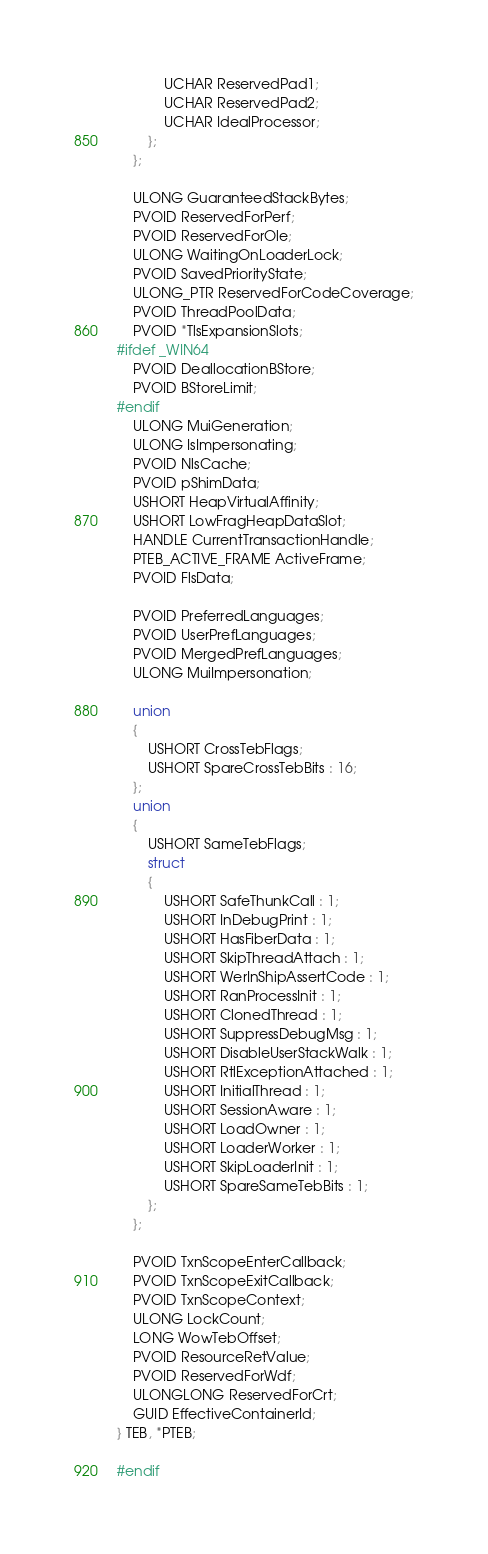Convert code to text. <code><loc_0><loc_0><loc_500><loc_500><_C_>            UCHAR ReservedPad1;
            UCHAR ReservedPad2;
            UCHAR IdealProcessor;
        };
    };

    ULONG GuaranteedStackBytes;
    PVOID ReservedForPerf;
    PVOID ReservedForOle;
    ULONG WaitingOnLoaderLock;
    PVOID SavedPriorityState;
    ULONG_PTR ReservedForCodeCoverage;
    PVOID ThreadPoolData;
    PVOID *TlsExpansionSlots;
#ifdef _WIN64
    PVOID DeallocationBStore;
    PVOID BStoreLimit;
#endif
    ULONG MuiGeneration;
    ULONG IsImpersonating;
    PVOID NlsCache;
    PVOID pShimData;
    USHORT HeapVirtualAffinity;
    USHORT LowFragHeapDataSlot;
    HANDLE CurrentTransactionHandle;
    PTEB_ACTIVE_FRAME ActiveFrame;
    PVOID FlsData;

    PVOID PreferredLanguages;
    PVOID UserPrefLanguages;
    PVOID MergedPrefLanguages;
    ULONG MuiImpersonation;

    union
    {
        USHORT CrossTebFlags;
        USHORT SpareCrossTebBits : 16;
    };
    union
    {
        USHORT SameTebFlags;
        struct
        {
            USHORT SafeThunkCall : 1;
            USHORT InDebugPrint : 1;
            USHORT HasFiberData : 1;
            USHORT SkipThreadAttach : 1;
            USHORT WerInShipAssertCode : 1;
            USHORT RanProcessInit : 1;
            USHORT ClonedThread : 1;
            USHORT SuppressDebugMsg : 1;
            USHORT DisableUserStackWalk : 1;
            USHORT RtlExceptionAttached : 1;
            USHORT InitialThread : 1;
            USHORT SessionAware : 1;
            USHORT LoadOwner : 1;
            USHORT LoaderWorker : 1;
            USHORT SkipLoaderInit : 1;
            USHORT SpareSameTebBits : 1;
        };
    };

    PVOID TxnScopeEnterCallback;
    PVOID TxnScopeExitCallback;
    PVOID TxnScopeContext;
    ULONG LockCount;
    LONG WowTebOffset;
    PVOID ResourceRetValue;
    PVOID ReservedForWdf;
    ULONGLONG ReservedForCrt;
    GUID EffectiveContainerId;
} TEB, *PTEB;

#endif
</code> 